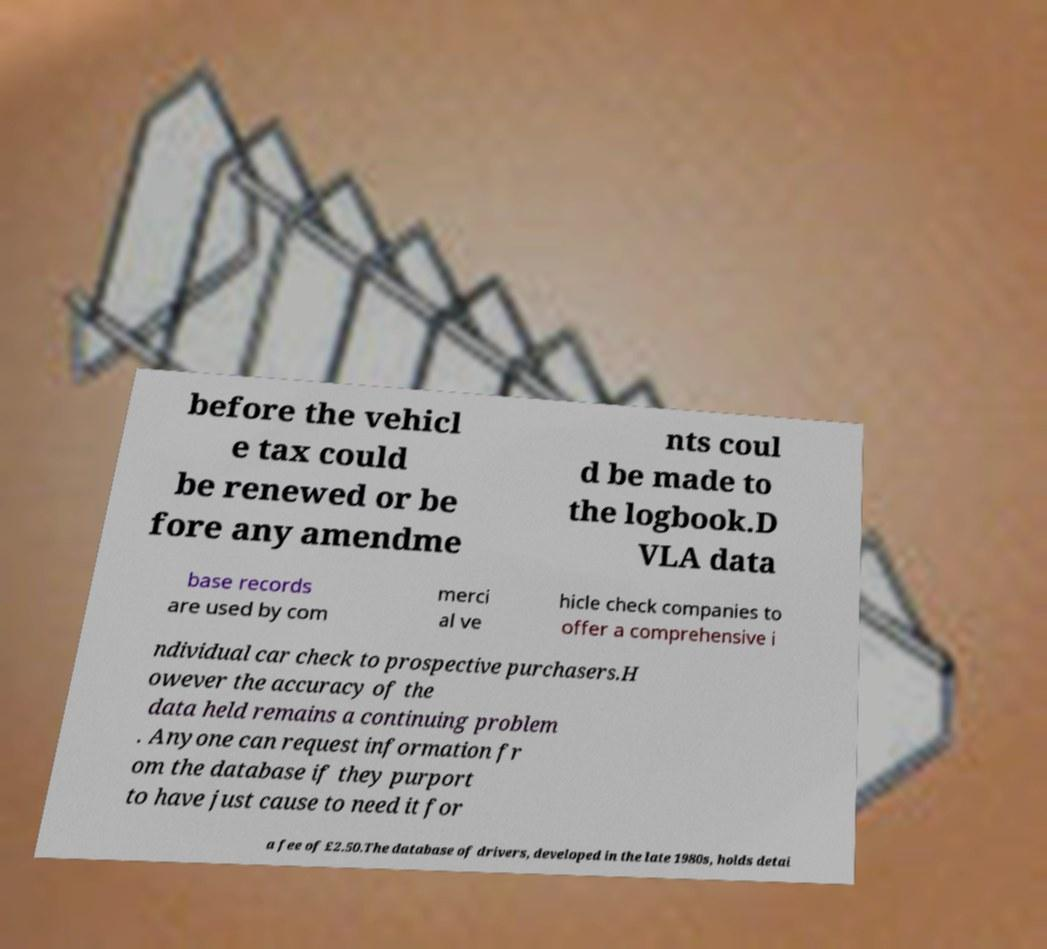There's text embedded in this image that I need extracted. Can you transcribe it verbatim? before the vehicl e tax could be renewed or be fore any amendme nts coul d be made to the logbook.D VLA data base records are used by com merci al ve hicle check companies to offer a comprehensive i ndividual car check to prospective purchasers.H owever the accuracy of the data held remains a continuing problem . Anyone can request information fr om the database if they purport to have just cause to need it for a fee of £2.50.The database of drivers, developed in the late 1980s, holds detai 